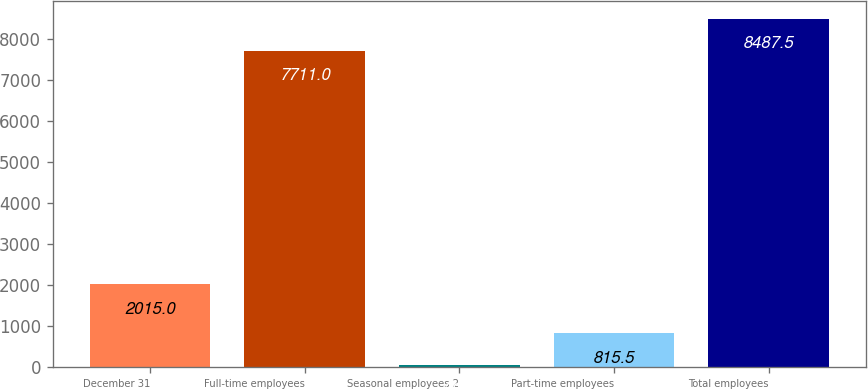<chart> <loc_0><loc_0><loc_500><loc_500><bar_chart><fcel>December 31<fcel>Full-time employees<fcel>Seasonal employees 2<fcel>Part-time employees<fcel>Total employees<nl><fcel>2015<fcel>7711<fcel>39<fcel>815.5<fcel>8487.5<nl></chart> 